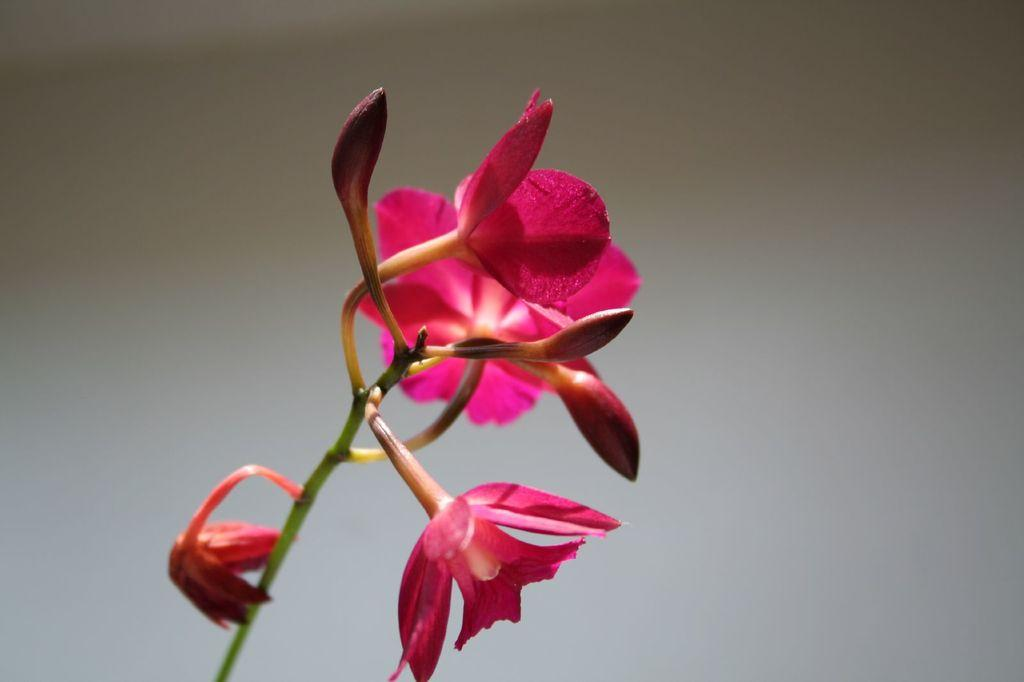What type of plants can be seen in the image? There are flowers in the image. What stage of growth are the flowers in? There are buds on the stems of the flowers. Can you describe the background of the image? The background of the image is blurred. What type of wheel is visible in the image? There is no wheel present in the image; it features flowers with buds on their stems and a blurred background. 